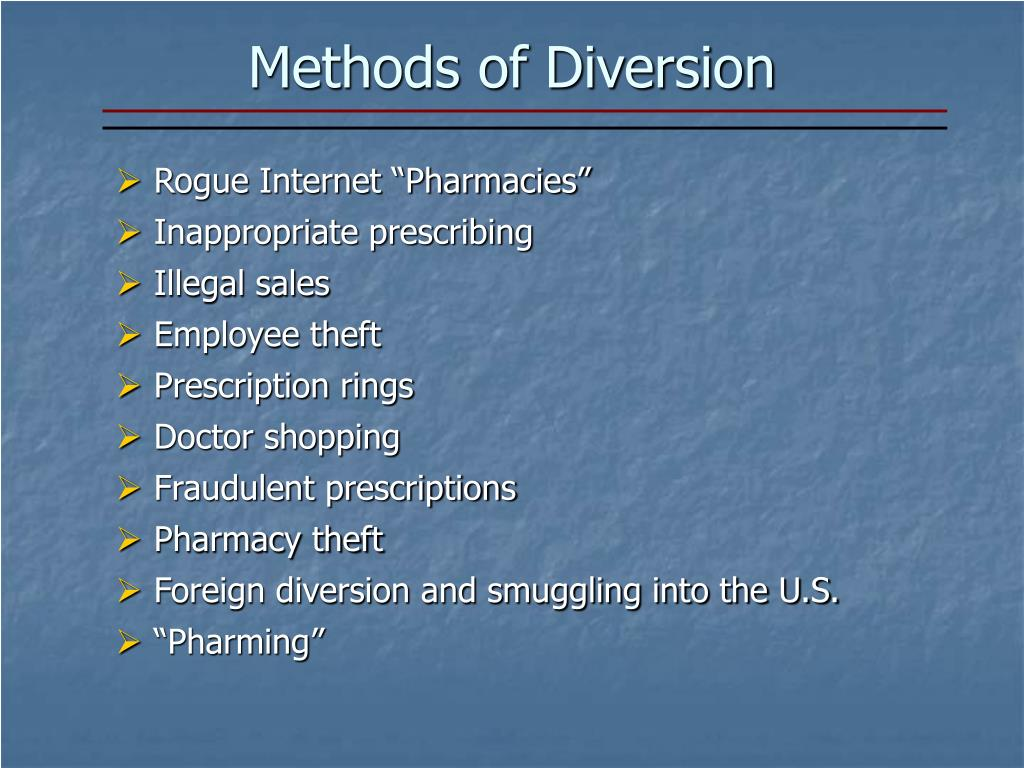Can you provide an example of a real-life scenario involving 'Foreign diversion and smuggling into the U.S.'? Certainly. A real-life example of 'Foreign diversion and smuggling into the U.S.' could involve a network of criminals obtaining prescription drugs from pharmaceutical companies in Country A, where the drugs are less expensive or more easily accessible due to less stringent regulations. These drugs are then smuggled into the U.S. through various means, such as hidden compartments in vehicles, international shipping containers, or even on the person of couriers. Once in the U.S., these drugs are sold on the black market, often at a significant markup. This illegal activity not only bypasses regulatory controls designed to ensure drug safety and efficacy but also circumvents pharmaceutical pricing structures, causing economic and public health challenges. 